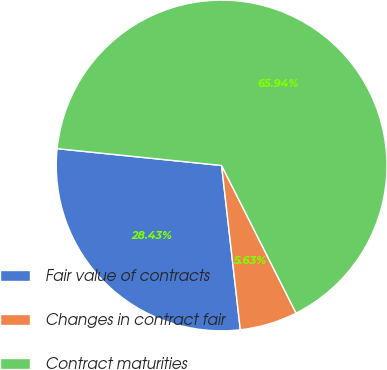Convert chart. <chart><loc_0><loc_0><loc_500><loc_500><pie_chart><fcel>Fair value of contracts<fcel>Changes in contract fair<fcel>Contract maturities<nl><fcel>28.43%<fcel>5.63%<fcel>65.94%<nl></chart> 